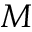Convert formula to latex. <formula><loc_0><loc_0><loc_500><loc_500>M</formula> 